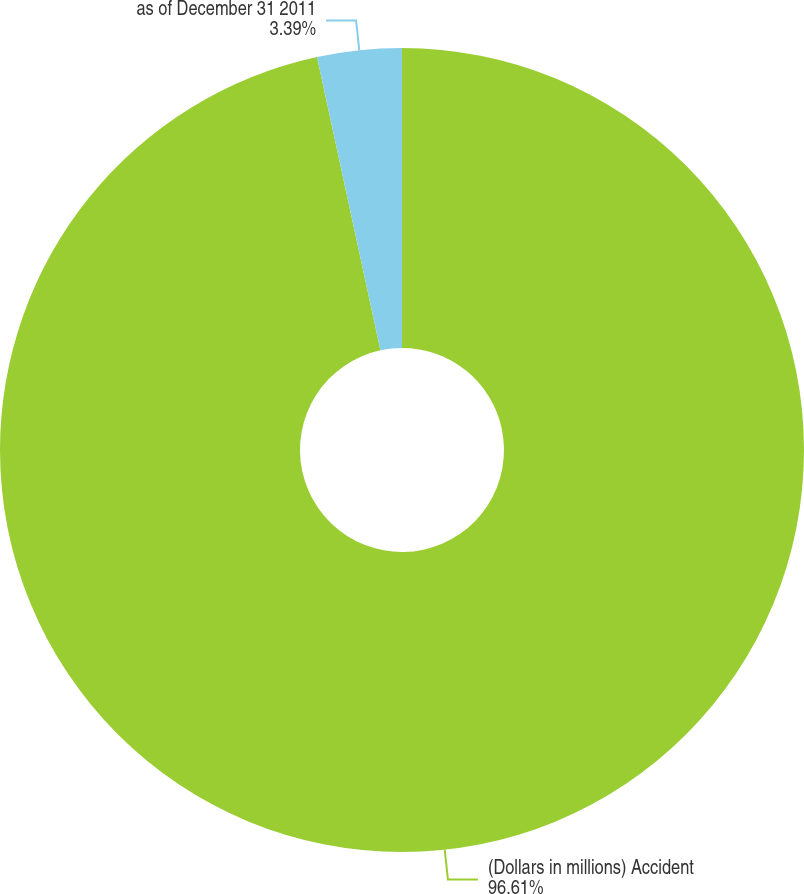Convert chart to OTSL. <chart><loc_0><loc_0><loc_500><loc_500><pie_chart><fcel>(Dollars in millions) Accident<fcel>as of December 31 2011<nl><fcel>96.61%<fcel>3.39%<nl></chart> 